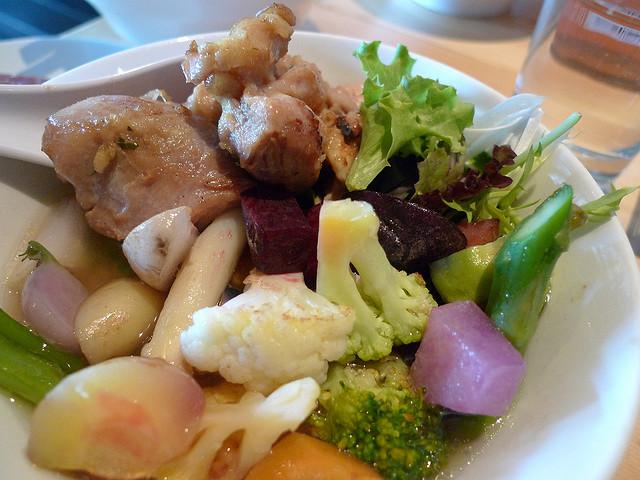Are there more than one types of vegetable in this bowl?
Give a very brief answer. Yes. Where is the broccoli?
Be succinct. In bowl. What color is the plate?
Be succinct. White. What is the orange colored vegetable?
Short answer required. Carrot. What is the purple thing on the plate?
Answer briefly. Onion. 